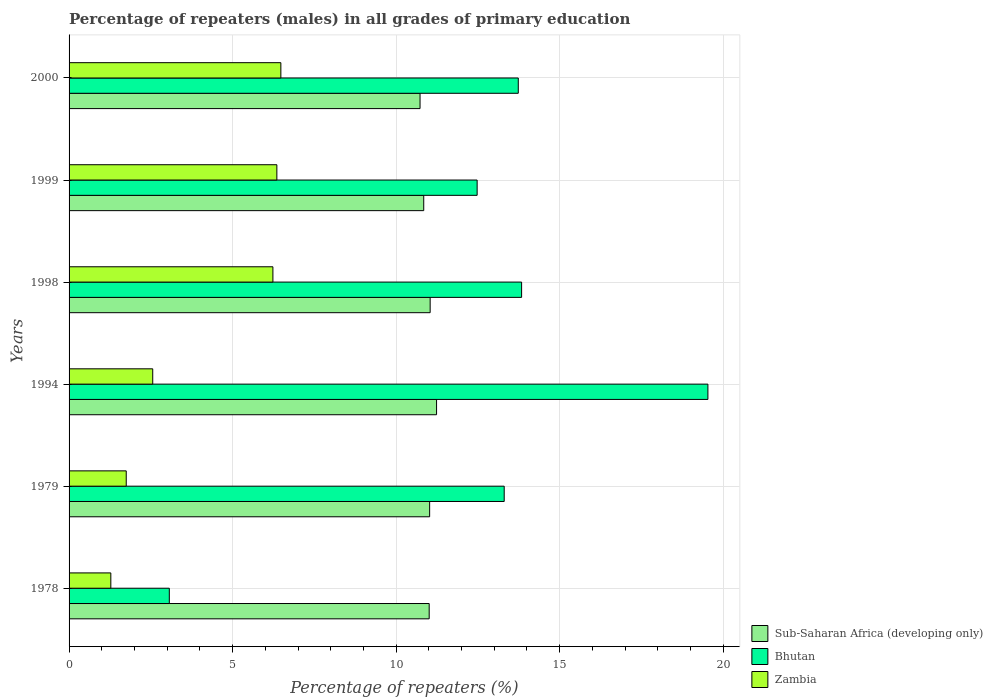How many groups of bars are there?
Provide a short and direct response. 6. How many bars are there on the 4th tick from the bottom?
Ensure brevity in your answer.  3. What is the label of the 5th group of bars from the top?
Give a very brief answer. 1979. In how many cases, is the number of bars for a given year not equal to the number of legend labels?
Your response must be concise. 0. What is the percentage of repeaters (males) in Bhutan in 1998?
Offer a very short reply. 13.84. Across all years, what is the maximum percentage of repeaters (males) in Bhutan?
Ensure brevity in your answer.  19.53. Across all years, what is the minimum percentage of repeaters (males) in Bhutan?
Offer a terse response. 3.06. What is the total percentage of repeaters (males) in Zambia in the graph?
Give a very brief answer. 24.64. What is the difference between the percentage of repeaters (males) in Sub-Saharan Africa (developing only) in 1979 and that in 1999?
Ensure brevity in your answer.  0.18. What is the difference between the percentage of repeaters (males) in Zambia in 1979 and the percentage of repeaters (males) in Bhutan in 1999?
Provide a short and direct response. -10.73. What is the average percentage of repeaters (males) in Bhutan per year?
Provide a succinct answer. 12.66. In the year 1999, what is the difference between the percentage of repeaters (males) in Bhutan and percentage of repeaters (males) in Zambia?
Your response must be concise. 6.12. In how many years, is the percentage of repeaters (males) in Sub-Saharan Africa (developing only) greater than 10 %?
Provide a succinct answer. 6. What is the ratio of the percentage of repeaters (males) in Sub-Saharan Africa (developing only) in 1979 to that in 1999?
Offer a very short reply. 1.02. What is the difference between the highest and the second highest percentage of repeaters (males) in Bhutan?
Give a very brief answer. 5.7. What is the difference between the highest and the lowest percentage of repeaters (males) in Bhutan?
Offer a very short reply. 16.47. Is the sum of the percentage of repeaters (males) in Zambia in 1979 and 1998 greater than the maximum percentage of repeaters (males) in Sub-Saharan Africa (developing only) across all years?
Give a very brief answer. No. What does the 3rd bar from the top in 1978 represents?
Make the answer very short. Sub-Saharan Africa (developing only). What does the 1st bar from the bottom in 1979 represents?
Your response must be concise. Sub-Saharan Africa (developing only). How many years are there in the graph?
Keep it short and to the point. 6. Are the values on the major ticks of X-axis written in scientific E-notation?
Give a very brief answer. No. Does the graph contain grids?
Ensure brevity in your answer.  Yes. Where does the legend appear in the graph?
Your response must be concise. Bottom right. What is the title of the graph?
Your answer should be compact. Percentage of repeaters (males) in all grades of primary education. Does "Timor-Leste" appear as one of the legend labels in the graph?
Make the answer very short. No. What is the label or title of the X-axis?
Offer a terse response. Percentage of repeaters (%). What is the label or title of the Y-axis?
Provide a succinct answer. Years. What is the Percentage of repeaters (%) of Sub-Saharan Africa (developing only) in 1978?
Keep it short and to the point. 11.01. What is the Percentage of repeaters (%) of Bhutan in 1978?
Offer a terse response. 3.06. What is the Percentage of repeaters (%) of Zambia in 1978?
Your answer should be compact. 1.28. What is the Percentage of repeaters (%) of Sub-Saharan Africa (developing only) in 1979?
Give a very brief answer. 11.02. What is the Percentage of repeaters (%) of Bhutan in 1979?
Provide a succinct answer. 13.3. What is the Percentage of repeaters (%) of Zambia in 1979?
Give a very brief answer. 1.75. What is the Percentage of repeaters (%) in Sub-Saharan Africa (developing only) in 1994?
Offer a terse response. 11.24. What is the Percentage of repeaters (%) in Bhutan in 1994?
Provide a succinct answer. 19.53. What is the Percentage of repeaters (%) in Zambia in 1994?
Offer a very short reply. 2.56. What is the Percentage of repeaters (%) of Sub-Saharan Africa (developing only) in 1998?
Provide a short and direct response. 11.04. What is the Percentage of repeaters (%) of Bhutan in 1998?
Offer a terse response. 13.84. What is the Percentage of repeaters (%) in Zambia in 1998?
Keep it short and to the point. 6.23. What is the Percentage of repeaters (%) of Sub-Saharan Africa (developing only) in 1999?
Your answer should be compact. 10.84. What is the Percentage of repeaters (%) in Bhutan in 1999?
Offer a terse response. 12.48. What is the Percentage of repeaters (%) of Zambia in 1999?
Make the answer very short. 6.35. What is the Percentage of repeaters (%) of Sub-Saharan Africa (developing only) in 2000?
Keep it short and to the point. 10.73. What is the Percentage of repeaters (%) of Bhutan in 2000?
Your response must be concise. 13.73. What is the Percentage of repeaters (%) in Zambia in 2000?
Your response must be concise. 6.48. Across all years, what is the maximum Percentage of repeaters (%) of Sub-Saharan Africa (developing only)?
Your answer should be very brief. 11.24. Across all years, what is the maximum Percentage of repeaters (%) of Bhutan?
Ensure brevity in your answer.  19.53. Across all years, what is the maximum Percentage of repeaters (%) of Zambia?
Your answer should be compact. 6.48. Across all years, what is the minimum Percentage of repeaters (%) of Sub-Saharan Africa (developing only)?
Provide a short and direct response. 10.73. Across all years, what is the minimum Percentage of repeaters (%) in Bhutan?
Make the answer very short. 3.06. Across all years, what is the minimum Percentage of repeaters (%) of Zambia?
Your answer should be compact. 1.28. What is the total Percentage of repeaters (%) of Sub-Saharan Africa (developing only) in the graph?
Keep it short and to the point. 65.88. What is the total Percentage of repeaters (%) of Bhutan in the graph?
Give a very brief answer. 75.95. What is the total Percentage of repeaters (%) of Zambia in the graph?
Provide a succinct answer. 24.64. What is the difference between the Percentage of repeaters (%) of Sub-Saharan Africa (developing only) in 1978 and that in 1979?
Provide a short and direct response. -0.01. What is the difference between the Percentage of repeaters (%) in Bhutan in 1978 and that in 1979?
Your answer should be very brief. -10.24. What is the difference between the Percentage of repeaters (%) in Zambia in 1978 and that in 1979?
Your response must be concise. -0.47. What is the difference between the Percentage of repeaters (%) of Sub-Saharan Africa (developing only) in 1978 and that in 1994?
Provide a succinct answer. -0.23. What is the difference between the Percentage of repeaters (%) in Bhutan in 1978 and that in 1994?
Provide a short and direct response. -16.47. What is the difference between the Percentage of repeaters (%) of Zambia in 1978 and that in 1994?
Your answer should be compact. -1.28. What is the difference between the Percentage of repeaters (%) in Sub-Saharan Africa (developing only) in 1978 and that in 1998?
Offer a terse response. -0.03. What is the difference between the Percentage of repeaters (%) of Bhutan in 1978 and that in 1998?
Give a very brief answer. -10.77. What is the difference between the Percentage of repeaters (%) of Zambia in 1978 and that in 1998?
Your response must be concise. -4.96. What is the difference between the Percentage of repeaters (%) in Sub-Saharan Africa (developing only) in 1978 and that in 1999?
Provide a succinct answer. 0.17. What is the difference between the Percentage of repeaters (%) of Bhutan in 1978 and that in 1999?
Keep it short and to the point. -9.41. What is the difference between the Percentage of repeaters (%) in Zambia in 1978 and that in 1999?
Give a very brief answer. -5.08. What is the difference between the Percentage of repeaters (%) in Sub-Saharan Africa (developing only) in 1978 and that in 2000?
Your answer should be very brief. 0.28. What is the difference between the Percentage of repeaters (%) in Bhutan in 1978 and that in 2000?
Keep it short and to the point. -10.67. What is the difference between the Percentage of repeaters (%) in Zambia in 1978 and that in 2000?
Your answer should be compact. -5.2. What is the difference between the Percentage of repeaters (%) of Sub-Saharan Africa (developing only) in 1979 and that in 1994?
Ensure brevity in your answer.  -0.21. What is the difference between the Percentage of repeaters (%) of Bhutan in 1979 and that in 1994?
Your answer should be compact. -6.23. What is the difference between the Percentage of repeaters (%) in Zambia in 1979 and that in 1994?
Give a very brief answer. -0.81. What is the difference between the Percentage of repeaters (%) in Sub-Saharan Africa (developing only) in 1979 and that in 1998?
Make the answer very short. -0.02. What is the difference between the Percentage of repeaters (%) in Bhutan in 1979 and that in 1998?
Make the answer very short. -0.53. What is the difference between the Percentage of repeaters (%) in Zambia in 1979 and that in 1998?
Offer a terse response. -4.48. What is the difference between the Percentage of repeaters (%) in Sub-Saharan Africa (developing only) in 1979 and that in 1999?
Provide a succinct answer. 0.18. What is the difference between the Percentage of repeaters (%) in Bhutan in 1979 and that in 1999?
Your response must be concise. 0.83. What is the difference between the Percentage of repeaters (%) in Zambia in 1979 and that in 1999?
Provide a short and direct response. -4.61. What is the difference between the Percentage of repeaters (%) in Sub-Saharan Africa (developing only) in 1979 and that in 2000?
Your response must be concise. 0.29. What is the difference between the Percentage of repeaters (%) in Bhutan in 1979 and that in 2000?
Provide a short and direct response. -0.43. What is the difference between the Percentage of repeaters (%) in Zambia in 1979 and that in 2000?
Your response must be concise. -4.73. What is the difference between the Percentage of repeaters (%) of Sub-Saharan Africa (developing only) in 1994 and that in 1998?
Your response must be concise. 0.2. What is the difference between the Percentage of repeaters (%) in Bhutan in 1994 and that in 1998?
Give a very brief answer. 5.7. What is the difference between the Percentage of repeaters (%) in Zambia in 1994 and that in 1998?
Provide a succinct answer. -3.67. What is the difference between the Percentage of repeaters (%) in Sub-Saharan Africa (developing only) in 1994 and that in 1999?
Offer a very short reply. 0.39. What is the difference between the Percentage of repeaters (%) in Bhutan in 1994 and that in 1999?
Your answer should be very brief. 7.06. What is the difference between the Percentage of repeaters (%) of Zambia in 1994 and that in 1999?
Ensure brevity in your answer.  -3.79. What is the difference between the Percentage of repeaters (%) in Sub-Saharan Africa (developing only) in 1994 and that in 2000?
Offer a very short reply. 0.5. What is the difference between the Percentage of repeaters (%) of Bhutan in 1994 and that in 2000?
Offer a terse response. 5.8. What is the difference between the Percentage of repeaters (%) of Zambia in 1994 and that in 2000?
Offer a terse response. -3.92. What is the difference between the Percentage of repeaters (%) in Sub-Saharan Africa (developing only) in 1998 and that in 1999?
Offer a terse response. 0.2. What is the difference between the Percentage of repeaters (%) of Bhutan in 1998 and that in 1999?
Offer a very short reply. 1.36. What is the difference between the Percentage of repeaters (%) in Zambia in 1998 and that in 1999?
Your answer should be compact. -0.12. What is the difference between the Percentage of repeaters (%) of Sub-Saharan Africa (developing only) in 1998 and that in 2000?
Your response must be concise. 0.31. What is the difference between the Percentage of repeaters (%) of Bhutan in 1998 and that in 2000?
Your answer should be very brief. 0.1. What is the difference between the Percentage of repeaters (%) of Zambia in 1998 and that in 2000?
Your response must be concise. -0.24. What is the difference between the Percentage of repeaters (%) in Sub-Saharan Africa (developing only) in 1999 and that in 2000?
Your answer should be compact. 0.11. What is the difference between the Percentage of repeaters (%) of Bhutan in 1999 and that in 2000?
Provide a short and direct response. -1.26. What is the difference between the Percentage of repeaters (%) in Zambia in 1999 and that in 2000?
Ensure brevity in your answer.  -0.12. What is the difference between the Percentage of repeaters (%) of Sub-Saharan Africa (developing only) in 1978 and the Percentage of repeaters (%) of Bhutan in 1979?
Your answer should be compact. -2.29. What is the difference between the Percentage of repeaters (%) of Sub-Saharan Africa (developing only) in 1978 and the Percentage of repeaters (%) of Zambia in 1979?
Give a very brief answer. 9.26. What is the difference between the Percentage of repeaters (%) in Bhutan in 1978 and the Percentage of repeaters (%) in Zambia in 1979?
Make the answer very short. 1.32. What is the difference between the Percentage of repeaters (%) of Sub-Saharan Africa (developing only) in 1978 and the Percentage of repeaters (%) of Bhutan in 1994?
Your response must be concise. -8.52. What is the difference between the Percentage of repeaters (%) in Sub-Saharan Africa (developing only) in 1978 and the Percentage of repeaters (%) in Zambia in 1994?
Give a very brief answer. 8.45. What is the difference between the Percentage of repeaters (%) of Bhutan in 1978 and the Percentage of repeaters (%) of Zambia in 1994?
Keep it short and to the point. 0.51. What is the difference between the Percentage of repeaters (%) in Sub-Saharan Africa (developing only) in 1978 and the Percentage of repeaters (%) in Bhutan in 1998?
Your response must be concise. -2.83. What is the difference between the Percentage of repeaters (%) in Sub-Saharan Africa (developing only) in 1978 and the Percentage of repeaters (%) in Zambia in 1998?
Make the answer very short. 4.78. What is the difference between the Percentage of repeaters (%) of Bhutan in 1978 and the Percentage of repeaters (%) of Zambia in 1998?
Offer a terse response. -3.17. What is the difference between the Percentage of repeaters (%) in Sub-Saharan Africa (developing only) in 1978 and the Percentage of repeaters (%) in Bhutan in 1999?
Your answer should be very brief. -1.47. What is the difference between the Percentage of repeaters (%) in Sub-Saharan Africa (developing only) in 1978 and the Percentage of repeaters (%) in Zambia in 1999?
Offer a terse response. 4.66. What is the difference between the Percentage of repeaters (%) in Bhutan in 1978 and the Percentage of repeaters (%) in Zambia in 1999?
Your answer should be very brief. -3.29. What is the difference between the Percentage of repeaters (%) in Sub-Saharan Africa (developing only) in 1978 and the Percentage of repeaters (%) in Bhutan in 2000?
Give a very brief answer. -2.72. What is the difference between the Percentage of repeaters (%) in Sub-Saharan Africa (developing only) in 1978 and the Percentage of repeaters (%) in Zambia in 2000?
Ensure brevity in your answer.  4.54. What is the difference between the Percentage of repeaters (%) in Bhutan in 1978 and the Percentage of repeaters (%) in Zambia in 2000?
Make the answer very short. -3.41. What is the difference between the Percentage of repeaters (%) of Sub-Saharan Africa (developing only) in 1979 and the Percentage of repeaters (%) of Bhutan in 1994?
Make the answer very short. -8.51. What is the difference between the Percentage of repeaters (%) of Sub-Saharan Africa (developing only) in 1979 and the Percentage of repeaters (%) of Zambia in 1994?
Your response must be concise. 8.47. What is the difference between the Percentage of repeaters (%) of Bhutan in 1979 and the Percentage of repeaters (%) of Zambia in 1994?
Provide a short and direct response. 10.75. What is the difference between the Percentage of repeaters (%) in Sub-Saharan Africa (developing only) in 1979 and the Percentage of repeaters (%) in Bhutan in 1998?
Ensure brevity in your answer.  -2.81. What is the difference between the Percentage of repeaters (%) of Sub-Saharan Africa (developing only) in 1979 and the Percentage of repeaters (%) of Zambia in 1998?
Ensure brevity in your answer.  4.79. What is the difference between the Percentage of repeaters (%) of Bhutan in 1979 and the Percentage of repeaters (%) of Zambia in 1998?
Ensure brevity in your answer.  7.07. What is the difference between the Percentage of repeaters (%) in Sub-Saharan Africa (developing only) in 1979 and the Percentage of repeaters (%) in Bhutan in 1999?
Your answer should be compact. -1.45. What is the difference between the Percentage of repeaters (%) in Sub-Saharan Africa (developing only) in 1979 and the Percentage of repeaters (%) in Zambia in 1999?
Make the answer very short. 4.67. What is the difference between the Percentage of repeaters (%) in Bhutan in 1979 and the Percentage of repeaters (%) in Zambia in 1999?
Ensure brevity in your answer.  6.95. What is the difference between the Percentage of repeaters (%) in Sub-Saharan Africa (developing only) in 1979 and the Percentage of repeaters (%) in Bhutan in 2000?
Make the answer very short. -2.71. What is the difference between the Percentage of repeaters (%) of Sub-Saharan Africa (developing only) in 1979 and the Percentage of repeaters (%) of Zambia in 2000?
Provide a succinct answer. 4.55. What is the difference between the Percentage of repeaters (%) of Bhutan in 1979 and the Percentage of repeaters (%) of Zambia in 2000?
Your response must be concise. 6.83. What is the difference between the Percentage of repeaters (%) of Sub-Saharan Africa (developing only) in 1994 and the Percentage of repeaters (%) of Bhutan in 1998?
Your answer should be compact. -2.6. What is the difference between the Percentage of repeaters (%) in Sub-Saharan Africa (developing only) in 1994 and the Percentage of repeaters (%) in Zambia in 1998?
Keep it short and to the point. 5. What is the difference between the Percentage of repeaters (%) of Bhutan in 1994 and the Percentage of repeaters (%) of Zambia in 1998?
Ensure brevity in your answer.  13.3. What is the difference between the Percentage of repeaters (%) of Sub-Saharan Africa (developing only) in 1994 and the Percentage of repeaters (%) of Bhutan in 1999?
Give a very brief answer. -1.24. What is the difference between the Percentage of repeaters (%) in Sub-Saharan Africa (developing only) in 1994 and the Percentage of repeaters (%) in Zambia in 1999?
Provide a succinct answer. 4.88. What is the difference between the Percentage of repeaters (%) of Bhutan in 1994 and the Percentage of repeaters (%) of Zambia in 1999?
Keep it short and to the point. 13.18. What is the difference between the Percentage of repeaters (%) in Sub-Saharan Africa (developing only) in 1994 and the Percentage of repeaters (%) in Bhutan in 2000?
Give a very brief answer. -2.5. What is the difference between the Percentage of repeaters (%) in Sub-Saharan Africa (developing only) in 1994 and the Percentage of repeaters (%) in Zambia in 2000?
Provide a succinct answer. 4.76. What is the difference between the Percentage of repeaters (%) in Bhutan in 1994 and the Percentage of repeaters (%) in Zambia in 2000?
Provide a short and direct response. 13.06. What is the difference between the Percentage of repeaters (%) of Sub-Saharan Africa (developing only) in 1998 and the Percentage of repeaters (%) of Bhutan in 1999?
Make the answer very short. -1.44. What is the difference between the Percentage of repeaters (%) in Sub-Saharan Africa (developing only) in 1998 and the Percentage of repeaters (%) in Zambia in 1999?
Offer a terse response. 4.69. What is the difference between the Percentage of repeaters (%) of Bhutan in 1998 and the Percentage of repeaters (%) of Zambia in 1999?
Ensure brevity in your answer.  7.48. What is the difference between the Percentage of repeaters (%) of Sub-Saharan Africa (developing only) in 1998 and the Percentage of repeaters (%) of Bhutan in 2000?
Make the answer very short. -2.69. What is the difference between the Percentage of repeaters (%) of Sub-Saharan Africa (developing only) in 1998 and the Percentage of repeaters (%) of Zambia in 2000?
Ensure brevity in your answer.  4.56. What is the difference between the Percentage of repeaters (%) of Bhutan in 1998 and the Percentage of repeaters (%) of Zambia in 2000?
Your response must be concise. 7.36. What is the difference between the Percentage of repeaters (%) of Sub-Saharan Africa (developing only) in 1999 and the Percentage of repeaters (%) of Bhutan in 2000?
Your answer should be compact. -2.89. What is the difference between the Percentage of repeaters (%) of Sub-Saharan Africa (developing only) in 1999 and the Percentage of repeaters (%) of Zambia in 2000?
Give a very brief answer. 4.37. What is the difference between the Percentage of repeaters (%) of Bhutan in 1999 and the Percentage of repeaters (%) of Zambia in 2000?
Ensure brevity in your answer.  6. What is the average Percentage of repeaters (%) of Sub-Saharan Africa (developing only) per year?
Keep it short and to the point. 10.98. What is the average Percentage of repeaters (%) in Bhutan per year?
Provide a short and direct response. 12.66. What is the average Percentage of repeaters (%) of Zambia per year?
Keep it short and to the point. 4.11. In the year 1978, what is the difference between the Percentage of repeaters (%) of Sub-Saharan Africa (developing only) and Percentage of repeaters (%) of Bhutan?
Provide a short and direct response. 7.95. In the year 1978, what is the difference between the Percentage of repeaters (%) of Sub-Saharan Africa (developing only) and Percentage of repeaters (%) of Zambia?
Offer a terse response. 9.73. In the year 1978, what is the difference between the Percentage of repeaters (%) in Bhutan and Percentage of repeaters (%) in Zambia?
Keep it short and to the point. 1.79. In the year 1979, what is the difference between the Percentage of repeaters (%) in Sub-Saharan Africa (developing only) and Percentage of repeaters (%) in Bhutan?
Ensure brevity in your answer.  -2.28. In the year 1979, what is the difference between the Percentage of repeaters (%) in Sub-Saharan Africa (developing only) and Percentage of repeaters (%) in Zambia?
Provide a short and direct response. 9.28. In the year 1979, what is the difference between the Percentage of repeaters (%) of Bhutan and Percentage of repeaters (%) of Zambia?
Provide a short and direct response. 11.56. In the year 1994, what is the difference between the Percentage of repeaters (%) of Sub-Saharan Africa (developing only) and Percentage of repeaters (%) of Bhutan?
Your answer should be very brief. -8.3. In the year 1994, what is the difference between the Percentage of repeaters (%) in Sub-Saharan Africa (developing only) and Percentage of repeaters (%) in Zambia?
Make the answer very short. 8.68. In the year 1994, what is the difference between the Percentage of repeaters (%) in Bhutan and Percentage of repeaters (%) in Zambia?
Provide a succinct answer. 16.97. In the year 1998, what is the difference between the Percentage of repeaters (%) of Sub-Saharan Africa (developing only) and Percentage of repeaters (%) of Bhutan?
Ensure brevity in your answer.  -2.8. In the year 1998, what is the difference between the Percentage of repeaters (%) in Sub-Saharan Africa (developing only) and Percentage of repeaters (%) in Zambia?
Ensure brevity in your answer.  4.81. In the year 1998, what is the difference between the Percentage of repeaters (%) of Bhutan and Percentage of repeaters (%) of Zambia?
Ensure brevity in your answer.  7.6. In the year 1999, what is the difference between the Percentage of repeaters (%) in Sub-Saharan Africa (developing only) and Percentage of repeaters (%) in Bhutan?
Make the answer very short. -1.63. In the year 1999, what is the difference between the Percentage of repeaters (%) of Sub-Saharan Africa (developing only) and Percentage of repeaters (%) of Zambia?
Keep it short and to the point. 4.49. In the year 1999, what is the difference between the Percentage of repeaters (%) of Bhutan and Percentage of repeaters (%) of Zambia?
Offer a very short reply. 6.12. In the year 2000, what is the difference between the Percentage of repeaters (%) in Sub-Saharan Africa (developing only) and Percentage of repeaters (%) in Bhutan?
Offer a very short reply. -3. In the year 2000, what is the difference between the Percentage of repeaters (%) of Sub-Saharan Africa (developing only) and Percentage of repeaters (%) of Zambia?
Offer a terse response. 4.26. In the year 2000, what is the difference between the Percentage of repeaters (%) of Bhutan and Percentage of repeaters (%) of Zambia?
Keep it short and to the point. 7.26. What is the ratio of the Percentage of repeaters (%) in Bhutan in 1978 to that in 1979?
Make the answer very short. 0.23. What is the ratio of the Percentage of repeaters (%) in Zambia in 1978 to that in 1979?
Give a very brief answer. 0.73. What is the ratio of the Percentage of repeaters (%) of Bhutan in 1978 to that in 1994?
Your response must be concise. 0.16. What is the ratio of the Percentage of repeaters (%) of Zambia in 1978 to that in 1994?
Offer a terse response. 0.5. What is the ratio of the Percentage of repeaters (%) of Bhutan in 1978 to that in 1998?
Provide a succinct answer. 0.22. What is the ratio of the Percentage of repeaters (%) of Zambia in 1978 to that in 1998?
Offer a terse response. 0.2. What is the ratio of the Percentage of repeaters (%) in Sub-Saharan Africa (developing only) in 1978 to that in 1999?
Make the answer very short. 1.02. What is the ratio of the Percentage of repeaters (%) in Bhutan in 1978 to that in 1999?
Your answer should be compact. 0.25. What is the ratio of the Percentage of repeaters (%) in Zambia in 1978 to that in 1999?
Make the answer very short. 0.2. What is the ratio of the Percentage of repeaters (%) of Bhutan in 1978 to that in 2000?
Make the answer very short. 0.22. What is the ratio of the Percentage of repeaters (%) in Zambia in 1978 to that in 2000?
Give a very brief answer. 0.2. What is the ratio of the Percentage of repeaters (%) in Sub-Saharan Africa (developing only) in 1979 to that in 1994?
Make the answer very short. 0.98. What is the ratio of the Percentage of repeaters (%) of Bhutan in 1979 to that in 1994?
Offer a very short reply. 0.68. What is the ratio of the Percentage of repeaters (%) of Zambia in 1979 to that in 1994?
Your answer should be compact. 0.68. What is the ratio of the Percentage of repeaters (%) in Sub-Saharan Africa (developing only) in 1979 to that in 1998?
Provide a succinct answer. 1. What is the ratio of the Percentage of repeaters (%) in Bhutan in 1979 to that in 1998?
Your response must be concise. 0.96. What is the ratio of the Percentage of repeaters (%) of Zambia in 1979 to that in 1998?
Your answer should be very brief. 0.28. What is the ratio of the Percentage of repeaters (%) in Sub-Saharan Africa (developing only) in 1979 to that in 1999?
Your response must be concise. 1.02. What is the ratio of the Percentage of repeaters (%) in Bhutan in 1979 to that in 1999?
Offer a terse response. 1.07. What is the ratio of the Percentage of repeaters (%) of Zambia in 1979 to that in 1999?
Keep it short and to the point. 0.28. What is the ratio of the Percentage of repeaters (%) in Sub-Saharan Africa (developing only) in 1979 to that in 2000?
Offer a terse response. 1.03. What is the ratio of the Percentage of repeaters (%) in Bhutan in 1979 to that in 2000?
Your response must be concise. 0.97. What is the ratio of the Percentage of repeaters (%) of Zambia in 1979 to that in 2000?
Your response must be concise. 0.27. What is the ratio of the Percentage of repeaters (%) in Sub-Saharan Africa (developing only) in 1994 to that in 1998?
Make the answer very short. 1.02. What is the ratio of the Percentage of repeaters (%) in Bhutan in 1994 to that in 1998?
Provide a short and direct response. 1.41. What is the ratio of the Percentage of repeaters (%) in Zambia in 1994 to that in 1998?
Keep it short and to the point. 0.41. What is the ratio of the Percentage of repeaters (%) in Sub-Saharan Africa (developing only) in 1994 to that in 1999?
Give a very brief answer. 1.04. What is the ratio of the Percentage of repeaters (%) in Bhutan in 1994 to that in 1999?
Offer a terse response. 1.57. What is the ratio of the Percentage of repeaters (%) of Zambia in 1994 to that in 1999?
Your response must be concise. 0.4. What is the ratio of the Percentage of repeaters (%) in Sub-Saharan Africa (developing only) in 1994 to that in 2000?
Make the answer very short. 1.05. What is the ratio of the Percentage of repeaters (%) in Bhutan in 1994 to that in 2000?
Keep it short and to the point. 1.42. What is the ratio of the Percentage of repeaters (%) in Zambia in 1994 to that in 2000?
Offer a terse response. 0.4. What is the ratio of the Percentage of repeaters (%) of Sub-Saharan Africa (developing only) in 1998 to that in 1999?
Give a very brief answer. 1.02. What is the ratio of the Percentage of repeaters (%) of Bhutan in 1998 to that in 1999?
Provide a succinct answer. 1.11. What is the ratio of the Percentage of repeaters (%) of Zambia in 1998 to that in 1999?
Your response must be concise. 0.98. What is the ratio of the Percentage of repeaters (%) of Sub-Saharan Africa (developing only) in 1998 to that in 2000?
Provide a short and direct response. 1.03. What is the ratio of the Percentage of repeaters (%) in Bhutan in 1998 to that in 2000?
Give a very brief answer. 1.01. What is the ratio of the Percentage of repeaters (%) in Zambia in 1998 to that in 2000?
Provide a short and direct response. 0.96. What is the ratio of the Percentage of repeaters (%) of Sub-Saharan Africa (developing only) in 1999 to that in 2000?
Your answer should be very brief. 1.01. What is the ratio of the Percentage of repeaters (%) of Bhutan in 1999 to that in 2000?
Give a very brief answer. 0.91. What is the ratio of the Percentage of repeaters (%) in Zambia in 1999 to that in 2000?
Give a very brief answer. 0.98. What is the difference between the highest and the second highest Percentage of repeaters (%) of Sub-Saharan Africa (developing only)?
Ensure brevity in your answer.  0.2. What is the difference between the highest and the second highest Percentage of repeaters (%) in Bhutan?
Your answer should be very brief. 5.7. What is the difference between the highest and the second highest Percentage of repeaters (%) in Zambia?
Make the answer very short. 0.12. What is the difference between the highest and the lowest Percentage of repeaters (%) in Sub-Saharan Africa (developing only)?
Give a very brief answer. 0.5. What is the difference between the highest and the lowest Percentage of repeaters (%) in Bhutan?
Ensure brevity in your answer.  16.47. What is the difference between the highest and the lowest Percentage of repeaters (%) in Zambia?
Ensure brevity in your answer.  5.2. 